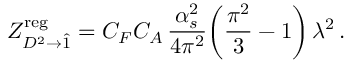Convert formula to latex. <formula><loc_0><loc_0><loc_500><loc_500>Z _ { D ^ { 2 } \to \hat { 1 } } ^ { r e g } = C _ { F } C _ { A } \, \frac { \alpha _ { s } ^ { 2 } } { 4 \pi ^ { 2 } } \left ( \frac { \pi ^ { 2 } } { 3 } - 1 \right ) \, \lambda ^ { 2 } \, .</formula> 